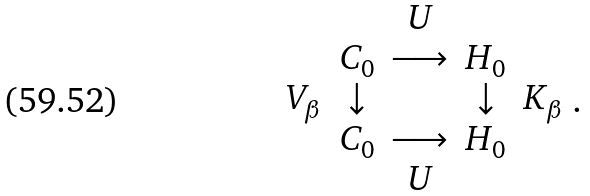Convert formula to latex. <formula><loc_0><loc_0><loc_500><loc_500>\begin{array} { c c c c c } & & U & & \\ & C _ { 0 } & \longrightarrow & H _ { 0 } & \\ V _ { \beta } & \downarrow & & \downarrow & K _ { \beta } \\ & C _ { 0 } & \longrightarrow & H _ { 0 } & \\ & & U & & \end{array} .</formula> 